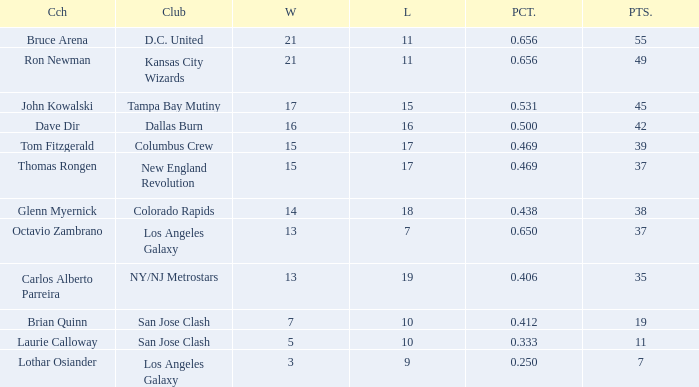What is the highest percent of Bruce Arena when he loses more than 11 games? None. 